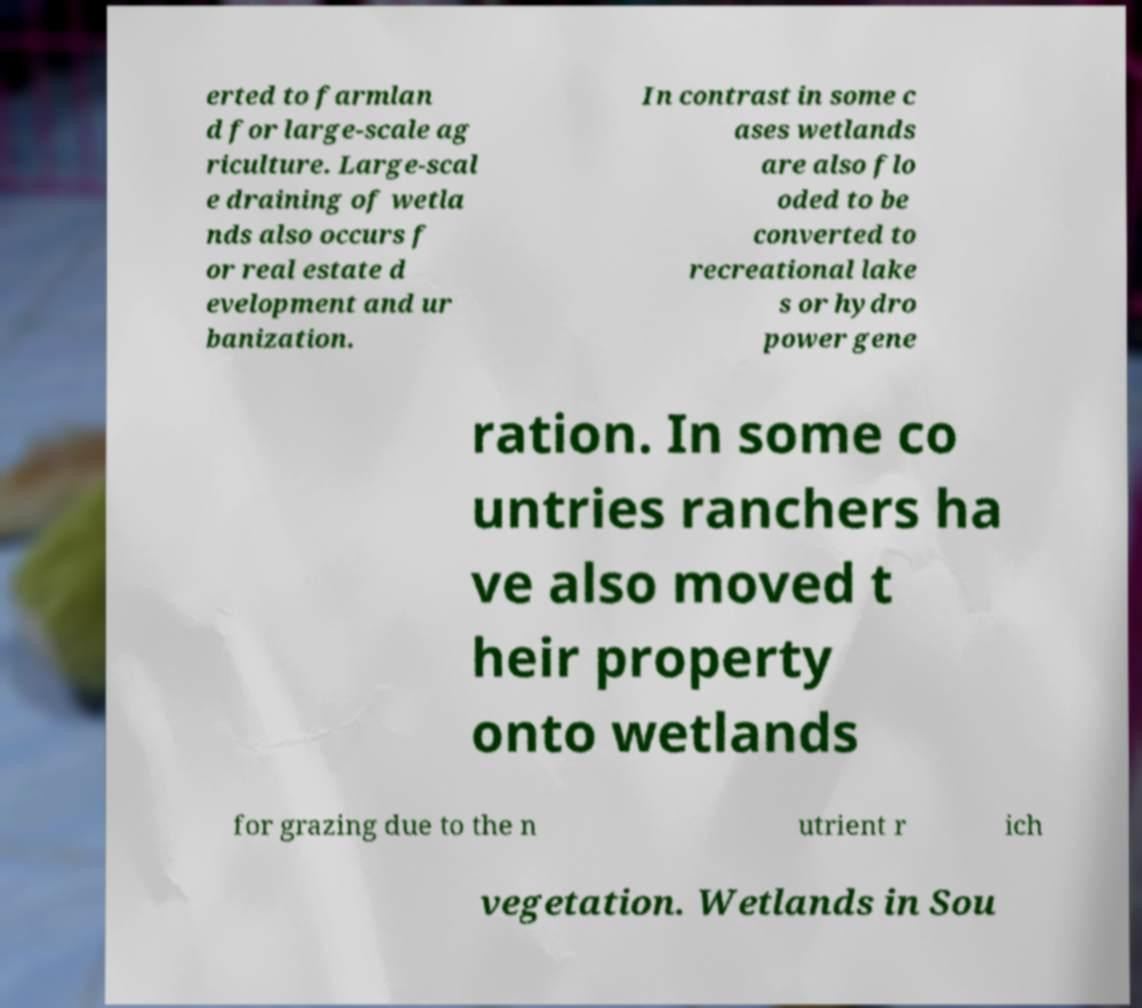Can you read and provide the text displayed in the image?This photo seems to have some interesting text. Can you extract and type it out for me? erted to farmlan d for large-scale ag riculture. Large-scal e draining of wetla nds also occurs f or real estate d evelopment and ur banization. In contrast in some c ases wetlands are also flo oded to be converted to recreational lake s or hydro power gene ration. In some co untries ranchers ha ve also moved t heir property onto wetlands for grazing due to the n utrient r ich vegetation. Wetlands in Sou 